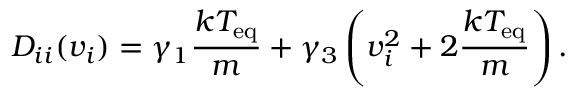<formula> <loc_0><loc_0><loc_500><loc_500>D _ { i i } ( v _ { i } ) = \gamma _ { 1 } \frac { k T _ { e q } } { m } + \gamma _ { 3 } \left ( v _ { i } ^ { 2 } + 2 \frac { k T _ { e q } } { m } \right ) .</formula> 